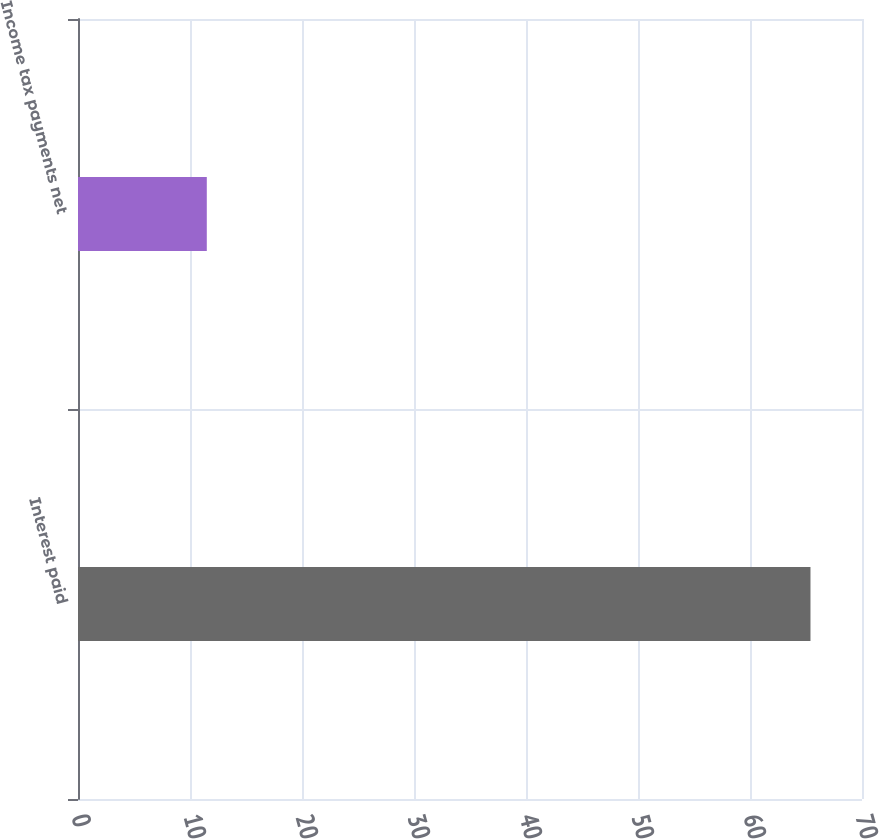Convert chart to OTSL. <chart><loc_0><loc_0><loc_500><loc_500><bar_chart><fcel>Interest paid<fcel>Income tax payments net<nl><fcel>65.4<fcel>11.5<nl></chart> 